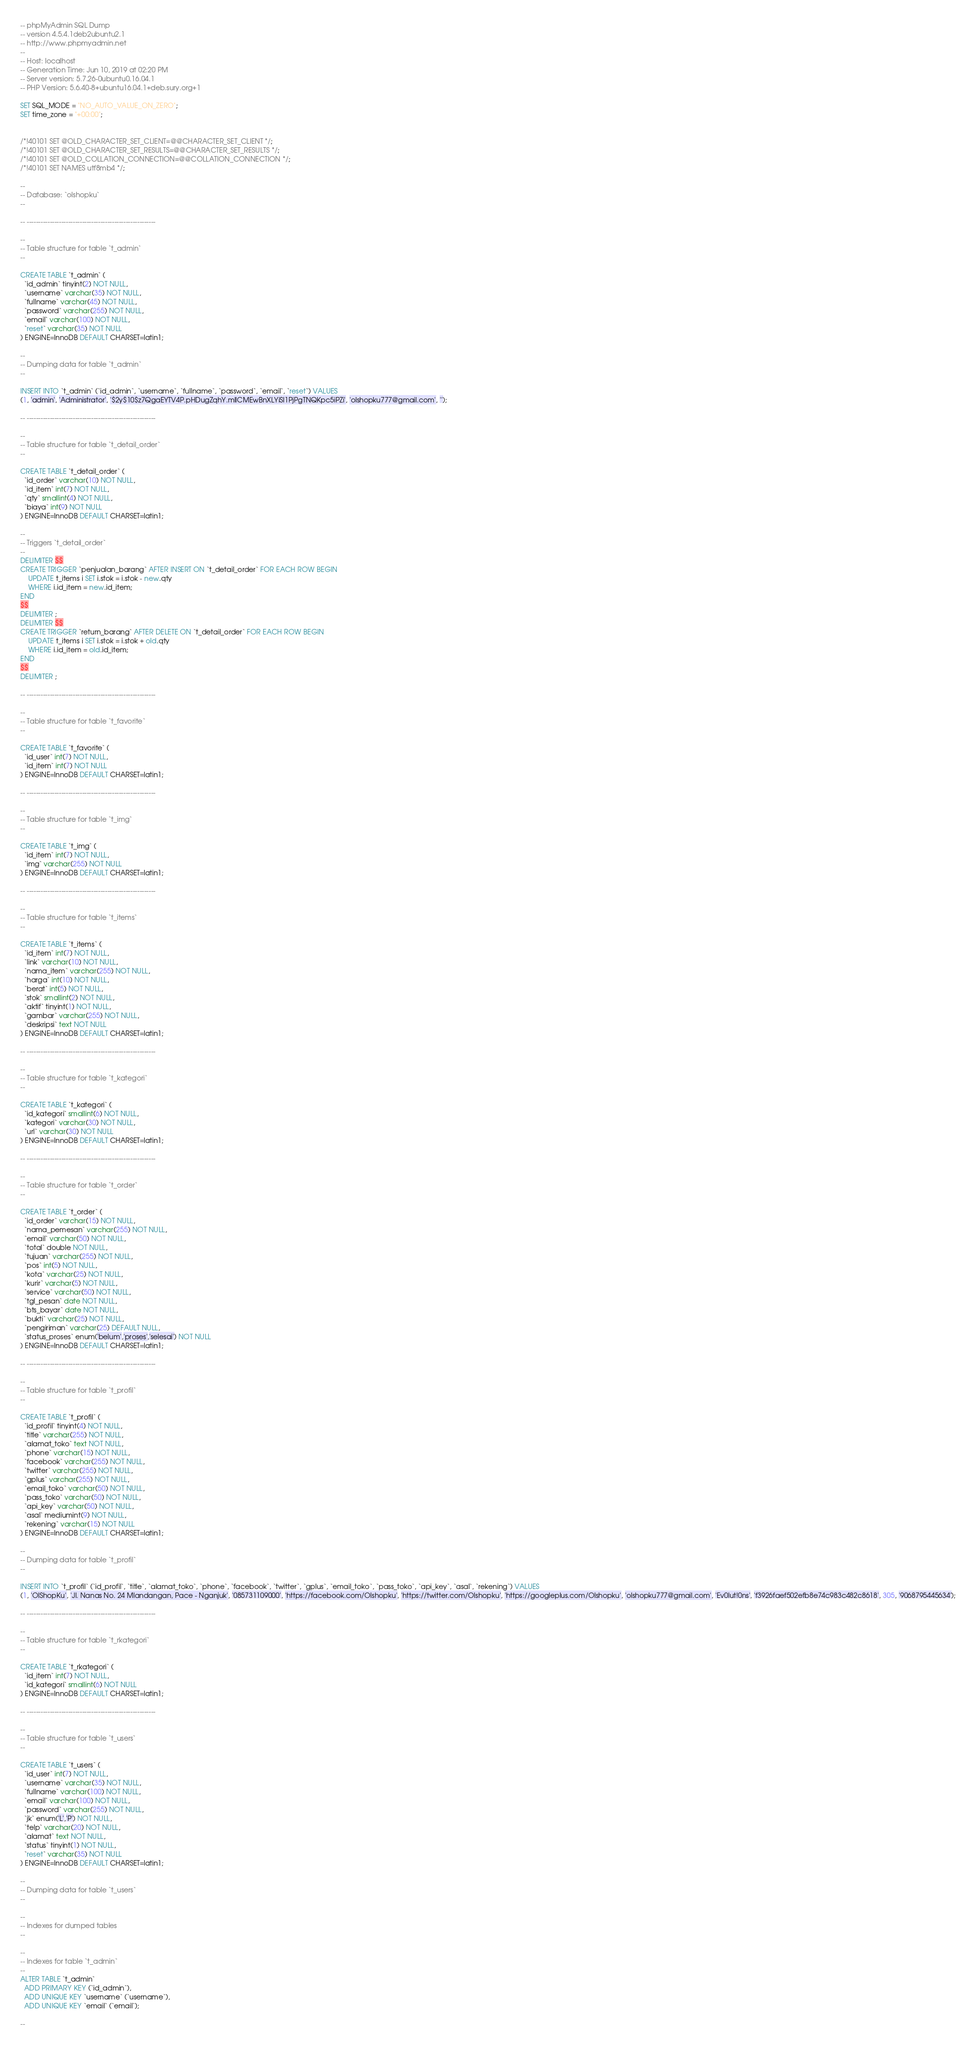<code> <loc_0><loc_0><loc_500><loc_500><_SQL_>-- phpMyAdmin SQL Dump
-- version 4.5.4.1deb2ubuntu2.1
-- http://www.phpmyadmin.net
--
-- Host: localhost
-- Generation Time: Jun 10, 2019 at 02:20 PM
-- Server version: 5.7.26-0ubuntu0.16.04.1
-- PHP Version: 5.6.40-8+ubuntu16.04.1+deb.sury.org+1

SET SQL_MODE = "NO_AUTO_VALUE_ON_ZERO";
SET time_zone = "+00:00";


/*!40101 SET @OLD_CHARACTER_SET_CLIENT=@@CHARACTER_SET_CLIENT */;
/*!40101 SET @OLD_CHARACTER_SET_RESULTS=@@CHARACTER_SET_RESULTS */;
/*!40101 SET @OLD_COLLATION_CONNECTION=@@COLLATION_CONNECTION */;
/*!40101 SET NAMES utf8mb4 */;

--
-- Database: `olshopku`
--

-- --------------------------------------------------------

--
-- Table structure for table `t_admin`
--

CREATE TABLE `t_admin` (
  `id_admin` tinyint(2) NOT NULL,
  `username` varchar(35) NOT NULL,
  `fullname` varchar(45) NOT NULL,
  `password` varchar(255) NOT NULL,
  `email` varchar(100) NOT NULL,
  `reset` varchar(35) NOT NULL
) ENGINE=InnoDB DEFAULT CHARSET=latin1;

--
-- Dumping data for table `t_admin`
--

INSERT INTO `t_admin` (`id_admin`, `username`, `fullname`, `password`, `email`, `reset`) VALUES
(1, 'admin', 'Administrator', '$2y$10$z7QgaEYTV4P.pHDugZqhY.mllCMEwBnXLYiSl1PjPgTNQKpc5iPZi', 'olshopku777@gmail.com', '');

-- --------------------------------------------------------

--
-- Table structure for table `t_detail_order`
--

CREATE TABLE `t_detail_order` (
  `id_order` varchar(10) NOT NULL,
  `id_item` int(7) NOT NULL,
  `qty` smallint(4) NOT NULL,
  `biaya` int(9) NOT NULL
) ENGINE=InnoDB DEFAULT CHARSET=latin1;

--
-- Triggers `t_detail_order`
--
DELIMITER $$
CREATE TRIGGER `penjualan_barang` AFTER INSERT ON `t_detail_order` FOR EACH ROW BEGIN
	UPDATE t_items i SET i.stok = i.stok - new.qty
    WHERE i.id_item = new.id_item;
END
$$
DELIMITER ;
DELIMITER $$
CREATE TRIGGER `return_barang` AFTER DELETE ON `t_detail_order` FOR EACH ROW BEGIN
	UPDATE t_items i SET i.stok = i.stok + old.qty
    WHERE i.id_item = old.id_item;
END
$$
DELIMITER ;

-- --------------------------------------------------------

--
-- Table structure for table `t_favorite`
--

CREATE TABLE `t_favorite` (
  `id_user` int(7) NOT NULL,
  `id_item` int(7) NOT NULL
) ENGINE=InnoDB DEFAULT CHARSET=latin1;

-- --------------------------------------------------------

--
-- Table structure for table `t_img`
--

CREATE TABLE `t_img` (
  `id_item` int(7) NOT NULL,
  `img` varchar(255) NOT NULL
) ENGINE=InnoDB DEFAULT CHARSET=latin1;

-- --------------------------------------------------------

--
-- Table structure for table `t_items`
--

CREATE TABLE `t_items` (
  `id_item` int(7) NOT NULL,
  `link` varchar(10) NOT NULL,
  `nama_item` varchar(255) NOT NULL,
  `harga` int(10) NOT NULL,
  `berat` int(5) NOT NULL,
  `stok` smallint(2) NOT NULL,
  `aktif` tinyint(1) NOT NULL,
  `gambar` varchar(255) NOT NULL,
  `deskripsi` text NOT NULL
) ENGINE=InnoDB DEFAULT CHARSET=latin1;

-- --------------------------------------------------------

--
-- Table structure for table `t_kategori`
--

CREATE TABLE `t_kategori` (
  `id_kategori` smallint(6) NOT NULL,
  `kategori` varchar(30) NOT NULL,
  `url` varchar(30) NOT NULL
) ENGINE=InnoDB DEFAULT CHARSET=latin1;

-- --------------------------------------------------------

--
-- Table structure for table `t_order`
--

CREATE TABLE `t_order` (
  `id_order` varchar(15) NOT NULL,
  `nama_pemesan` varchar(255) NOT NULL,
  `email` varchar(50) NOT NULL,
  `total` double NOT NULL,
  `tujuan` varchar(255) NOT NULL,
  `pos` int(5) NOT NULL,
  `kota` varchar(25) NOT NULL,
  `kurir` varchar(5) NOT NULL,
  `service` varchar(50) NOT NULL,
  `tgl_pesan` date NOT NULL,
  `bts_bayar` date NOT NULL,
  `bukti` varchar(25) NOT NULL,
  `pengiriman` varchar(25) DEFAULT NULL,
  `status_proses` enum('belum','proses','selesai') NOT NULL
) ENGINE=InnoDB DEFAULT CHARSET=latin1;

-- --------------------------------------------------------

--
-- Table structure for table `t_profil`
--

CREATE TABLE `t_profil` (
  `id_profil` tinyint(4) NOT NULL,
  `title` varchar(255) NOT NULL,
  `alamat_toko` text NOT NULL,
  `phone` varchar(15) NOT NULL,
  `facebook` varchar(255) NOT NULL,
  `twitter` varchar(255) NOT NULL,
  `gplus` varchar(255) NOT NULL,
  `email_toko` varchar(50) NOT NULL,
  `pass_toko` varchar(50) NOT NULL,
  `api_key` varchar(50) NOT NULL,
  `asal` mediumint(9) NOT NULL,
  `rekening` varchar(15) NOT NULL
) ENGINE=InnoDB DEFAULT CHARSET=latin1;

--
-- Dumping data for table `t_profil`
--

INSERT INTO `t_profil` (`id_profil`, `title`, `alamat_toko`, `phone`, `facebook`, `twitter`, `gplus`, `email_toko`, `pass_toko`, `api_key`, `asal`, `rekening`) VALUES
(1, 'OlShopKu', 'Jl. Nanas No. 24 Mlandangan, Pace - Nganjuk', '085731109000', 'https://facebook.com/Olshopku', 'https://twitter.com/Olshopku', 'https://googleplus.com/Olshopku', 'olshopku777@gmail.com', 'Ev0lut!0ns', 'f3926faef502efb8e74c983c482c8618', 305, '9068795445634');

-- --------------------------------------------------------

--
-- Table structure for table `t_rkategori`
--

CREATE TABLE `t_rkategori` (
  `id_item` int(7) NOT NULL,
  `id_kategori` smallint(6) NOT NULL
) ENGINE=InnoDB DEFAULT CHARSET=latin1;

-- --------------------------------------------------------

--
-- Table structure for table `t_users`
--

CREATE TABLE `t_users` (
  `id_user` int(7) NOT NULL,
  `username` varchar(35) NOT NULL,
  `fullname` varchar(100) NOT NULL,
  `email` varchar(100) NOT NULL,
  `password` varchar(255) NOT NULL,
  `jk` enum('L','P') NOT NULL,
  `telp` varchar(20) NOT NULL,
  `alamat` text NOT NULL,
  `status` tinyint(1) NOT NULL,
  `reset` varchar(35) NOT NULL
) ENGINE=InnoDB DEFAULT CHARSET=latin1;

--
-- Dumping data for table `t_users`
--

--
-- Indexes for dumped tables
--

--
-- Indexes for table `t_admin`
--
ALTER TABLE `t_admin`
  ADD PRIMARY KEY (`id_admin`),
  ADD UNIQUE KEY `username` (`username`),
  ADD UNIQUE KEY `email` (`email`);

--</code> 